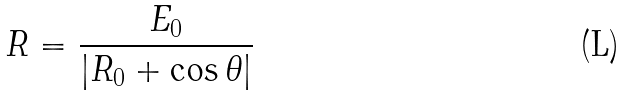Convert formula to latex. <formula><loc_0><loc_0><loc_500><loc_500>R = \frac { E _ { 0 } } { | R _ { 0 } + \cos \theta | }</formula> 